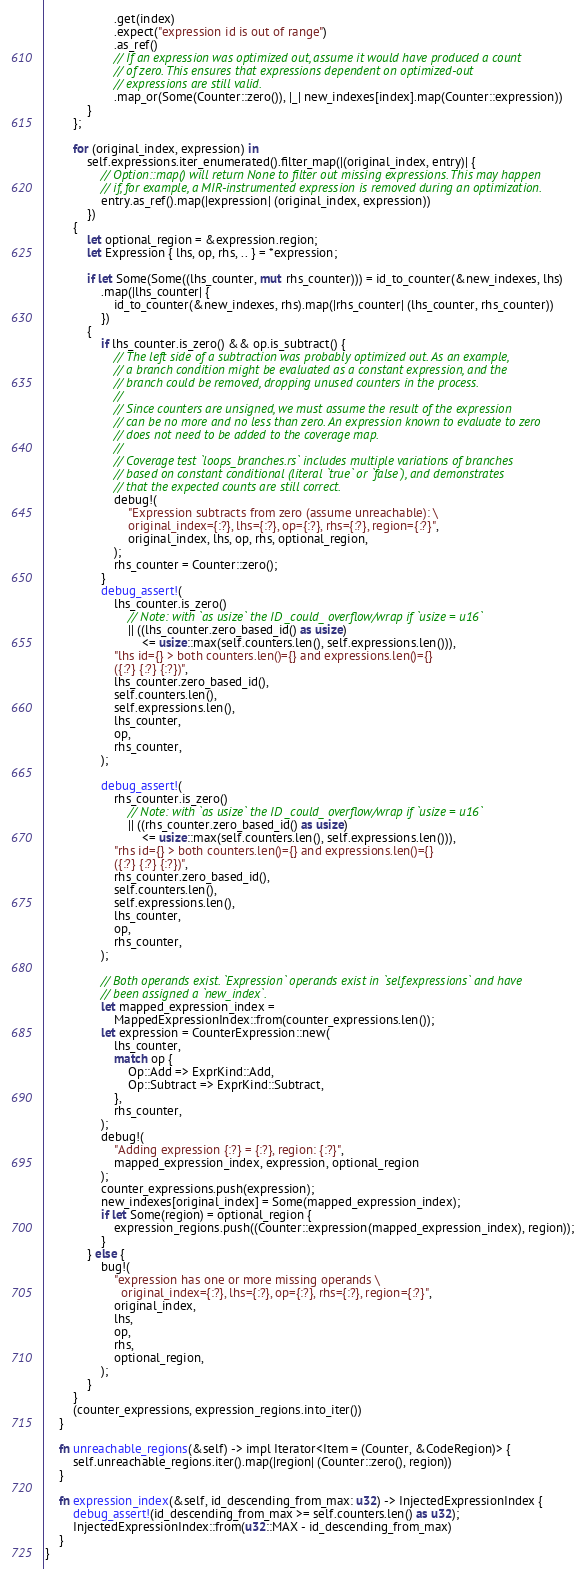<code> <loc_0><loc_0><loc_500><loc_500><_Rust_>                    .get(index)
                    .expect("expression id is out of range")
                    .as_ref()
                    // If an expression was optimized out, assume it would have produced a count
                    // of zero. This ensures that expressions dependent on optimized-out
                    // expressions are still valid.
                    .map_or(Some(Counter::zero()), |_| new_indexes[index].map(Counter::expression))
            }
        };

        for (original_index, expression) in
            self.expressions.iter_enumerated().filter_map(|(original_index, entry)| {
                // Option::map() will return None to filter out missing expressions. This may happen
                // if, for example, a MIR-instrumented expression is removed during an optimization.
                entry.as_ref().map(|expression| (original_index, expression))
            })
        {
            let optional_region = &expression.region;
            let Expression { lhs, op, rhs, .. } = *expression;

            if let Some(Some((lhs_counter, mut rhs_counter))) = id_to_counter(&new_indexes, lhs)
                .map(|lhs_counter| {
                    id_to_counter(&new_indexes, rhs).map(|rhs_counter| (lhs_counter, rhs_counter))
                })
            {
                if lhs_counter.is_zero() && op.is_subtract() {
                    // The left side of a subtraction was probably optimized out. As an example,
                    // a branch condition might be evaluated as a constant expression, and the
                    // branch could be removed, dropping unused counters in the process.
                    //
                    // Since counters are unsigned, we must assume the result of the expression
                    // can be no more and no less than zero. An expression known to evaluate to zero
                    // does not need to be added to the coverage map.
                    //
                    // Coverage test `loops_branches.rs` includes multiple variations of branches
                    // based on constant conditional (literal `true` or `false`), and demonstrates
                    // that the expected counts are still correct.
                    debug!(
                        "Expression subtracts from zero (assume unreachable): \
                        original_index={:?}, lhs={:?}, op={:?}, rhs={:?}, region={:?}",
                        original_index, lhs, op, rhs, optional_region,
                    );
                    rhs_counter = Counter::zero();
                }
                debug_assert!(
                    lhs_counter.is_zero()
                        // Note: with `as usize` the ID _could_ overflow/wrap if `usize = u16`
                        || ((lhs_counter.zero_based_id() as usize)
                            <= usize::max(self.counters.len(), self.expressions.len())),
                    "lhs id={} > both counters.len()={} and expressions.len()={}
                    ({:?} {:?} {:?})",
                    lhs_counter.zero_based_id(),
                    self.counters.len(),
                    self.expressions.len(),
                    lhs_counter,
                    op,
                    rhs_counter,
                );

                debug_assert!(
                    rhs_counter.is_zero()
                        // Note: with `as usize` the ID _could_ overflow/wrap if `usize = u16`
                        || ((rhs_counter.zero_based_id() as usize)
                            <= usize::max(self.counters.len(), self.expressions.len())),
                    "rhs id={} > both counters.len()={} and expressions.len()={}
                    ({:?} {:?} {:?})",
                    rhs_counter.zero_based_id(),
                    self.counters.len(),
                    self.expressions.len(),
                    lhs_counter,
                    op,
                    rhs_counter,
                );

                // Both operands exist. `Expression` operands exist in `self.expressions` and have
                // been assigned a `new_index`.
                let mapped_expression_index =
                    MappedExpressionIndex::from(counter_expressions.len());
                let expression = CounterExpression::new(
                    lhs_counter,
                    match op {
                        Op::Add => ExprKind::Add,
                        Op::Subtract => ExprKind::Subtract,
                    },
                    rhs_counter,
                );
                debug!(
                    "Adding expression {:?} = {:?}, region: {:?}",
                    mapped_expression_index, expression, optional_region
                );
                counter_expressions.push(expression);
                new_indexes[original_index] = Some(mapped_expression_index);
                if let Some(region) = optional_region {
                    expression_regions.push((Counter::expression(mapped_expression_index), region));
                }
            } else {
                bug!(
                    "expression has one or more missing operands \
                      original_index={:?}, lhs={:?}, op={:?}, rhs={:?}, region={:?}",
                    original_index,
                    lhs,
                    op,
                    rhs,
                    optional_region,
                );
            }
        }
        (counter_expressions, expression_regions.into_iter())
    }

    fn unreachable_regions(&self) -> impl Iterator<Item = (Counter, &CodeRegion)> {
        self.unreachable_regions.iter().map(|region| (Counter::zero(), region))
    }

    fn expression_index(&self, id_descending_from_max: u32) -> InjectedExpressionIndex {
        debug_assert!(id_descending_from_max >= self.counters.len() as u32);
        InjectedExpressionIndex::from(u32::MAX - id_descending_from_max)
    }
}
</code> 